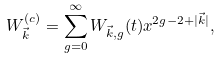Convert formula to latex. <formula><loc_0><loc_0><loc_500><loc_500>W _ { \vec { k } } ^ { ( c ) } = \sum _ { g = 0 } ^ { \infty } W _ { \vec { k } , g } ( t ) x ^ { 2 g - 2 + | \vec { k } | } ,</formula> 